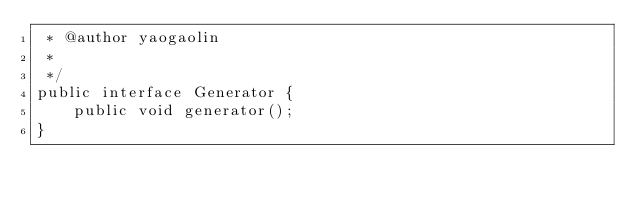<code> <loc_0><loc_0><loc_500><loc_500><_Java_> * @author yaogaolin
 *
 */
public interface Generator {
	public void generator();
}
</code> 